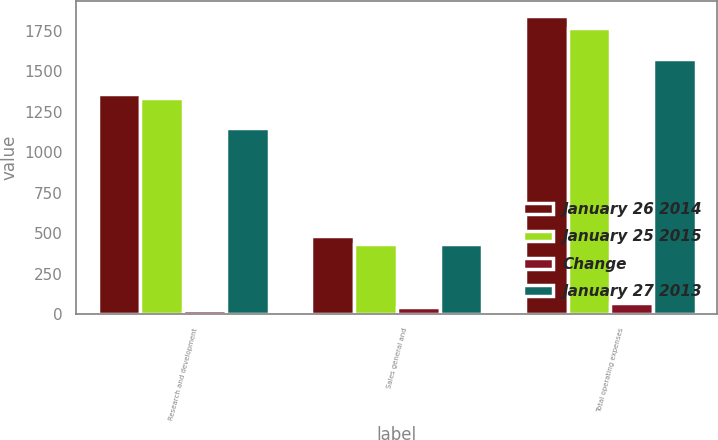Convert chart. <chart><loc_0><loc_0><loc_500><loc_500><stacked_bar_chart><ecel><fcel>Research and development<fcel>Sales general and<fcel>Total operating expenses<nl><fcel>January 26 2014<fcel>1359.7<fcel>480.8<fcel>1840.5<nl><fcel>January 25 2015<fcel>1335.8<fcel>435.7<fcel>1771.5<nl><fcel>Change<fcel>23.9<fcel>45.1<fcel>69<nl><fcel>January 27 2013<fcel>1147.3<fcel>430.8<fcel>1578.1<nl></chart> 